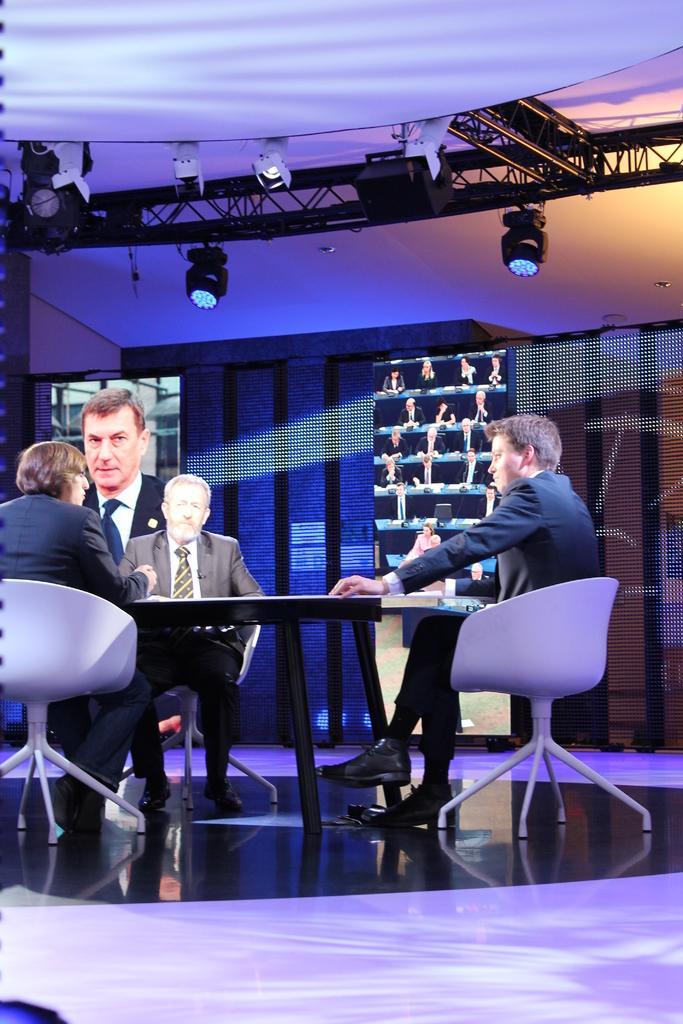In one or two sentences, can you explain what this image depicts? In this image there are group of people who are sitting on a chair in front of them there is one table it seems that they are talking on the top of the image there is one ceiling and in the middle of the image there is one wall and lights are there and on the background there is screen. 